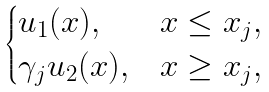<formula> <loc_0><loc_0><loc_500><loc_500>\begin{cases} u _ { 1 } ( x ) , & x \leq x _ { j } , \\ \gamma _ { j } u _ { 2 } ( x ) , & x \geq x _ { j } , \end{cases}</formula> 